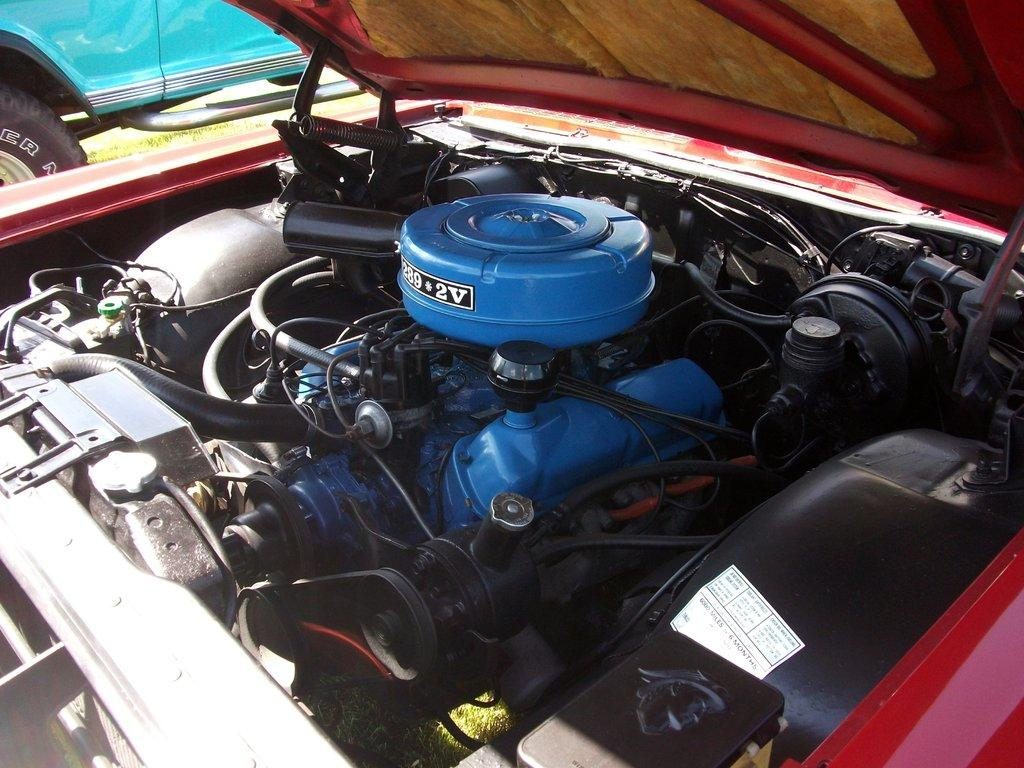What type of objects can be found inside the vehicle in the image? There are devices in the vehicle. What color is the vehicle in the image? The vehicle is blue. Where is the vehicle located in the image? The vehicle is on grassland. How many bubbles can be seen around the vehicle in the image? There are no bubbles present in the image. What type of animal can be seen sitting on the vehicle in the image? There are no animals present in the image. 